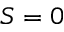<formula> <loc_0><loc_0><loc_500><loc_500>S = 0</formula> 